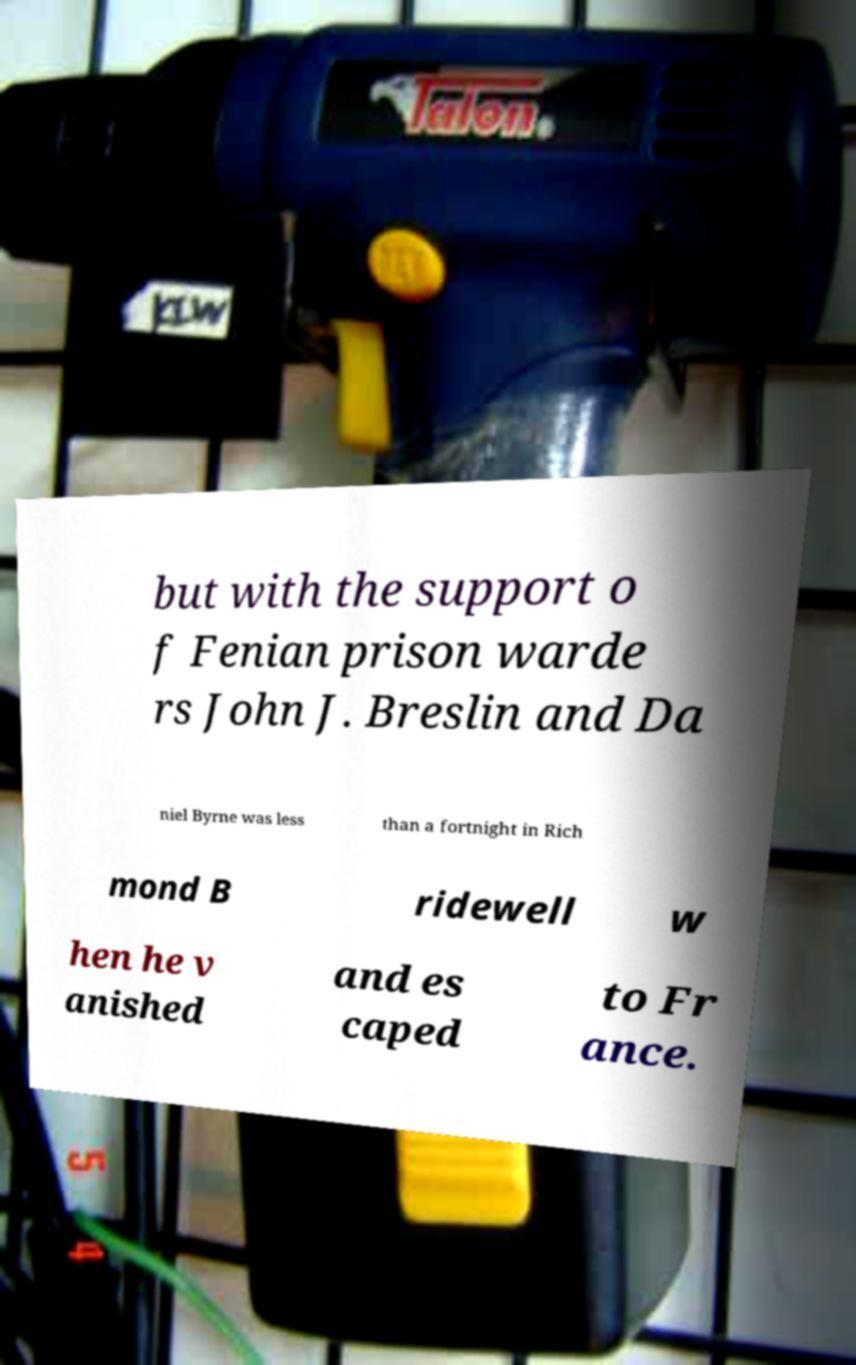What messages or text are displayed in this image? I need them in a readable, typed format. but with the support o f Fenian prison warde rs John J. Breslin and Da niel Byrne was less than a fortnight in Rich mond B ridewell w hen he v anished and es caped to Fr ance. 